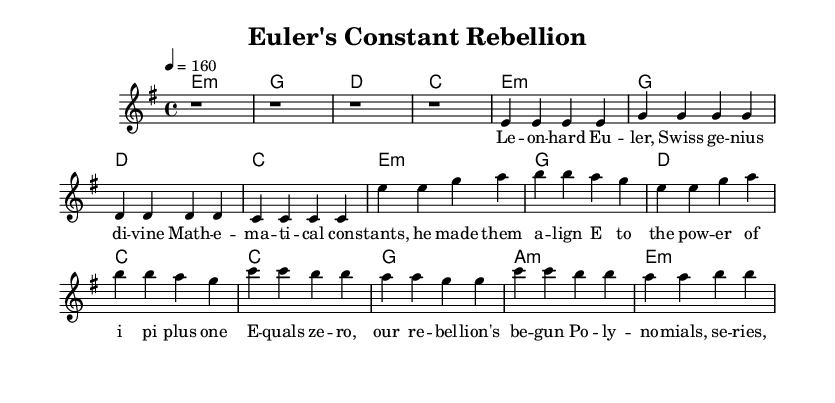What is the key signature of this music? The key signature is e minor, which includes one sharp (F#). It's indicated at the beginning of the score in the key section.
Answer: e minor What is the time signature of this music? The time signature is 4/4, which means there are four beats per measure. This is also marked at the beginning of the score.
Answer: 4/4 What is the tempo marking of this music? The tempo marking is 4 = 160, indicating that there should be 160 quarter note beats per minute. This is specified in the tempo section of the score.
Answer: 160 How many measures are in the verse section? The verse section consists of four measures, indicated by the melodic notation that spans from the start of the verse to the end.
Answer: 4 What is the chord progression during the chorus? The chord progression during the chorus is e minor, g major, d major, c major, which reflects a common pop-punk chord structure throughout this section. This is found in the harmonies part of the score.
Answer: e minor, g major, d major, c major Which mathematician is celebrated in this piece? The piece celebrates Leonhard Euler, as mentioned in the lyrics of the verse. He is referred to as a "Swiss genius divine." This is indicated clearly in the lyrics section.
Answer: Leonhard Euler What do the lyrics in the bridge highlight? The lyrics in the bridge highlight "polynomials, series, and infinite sums," showcasing the depth of Euler's contributions to mathematics. This can be derived from the lyrics that conclude the bridge section.
Answer: Polynomials, series, infinite sums 